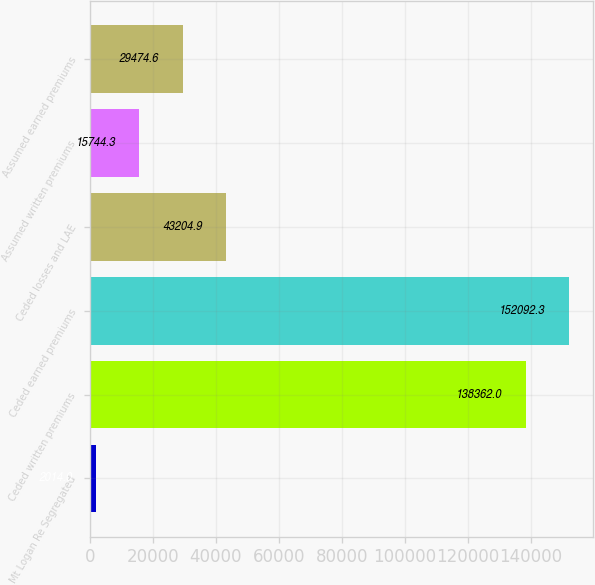Convert chart. <chart><loc_0><loc_0><loc_500><loc_500><bar_chart><fcel>Mt Logan Re Segregated<fcel>Ceded written premiums<fcel>Ceded earned premiums<fcel>Ceded losses and LAE<fcel>Assumed written premiums<fcel>Assumed earned premiums<nl><fcel>2014<fcel>138362<fcel>152092<fcel>43204.9<fcel>15744.3<fcel>29474.6<nl></chart> 